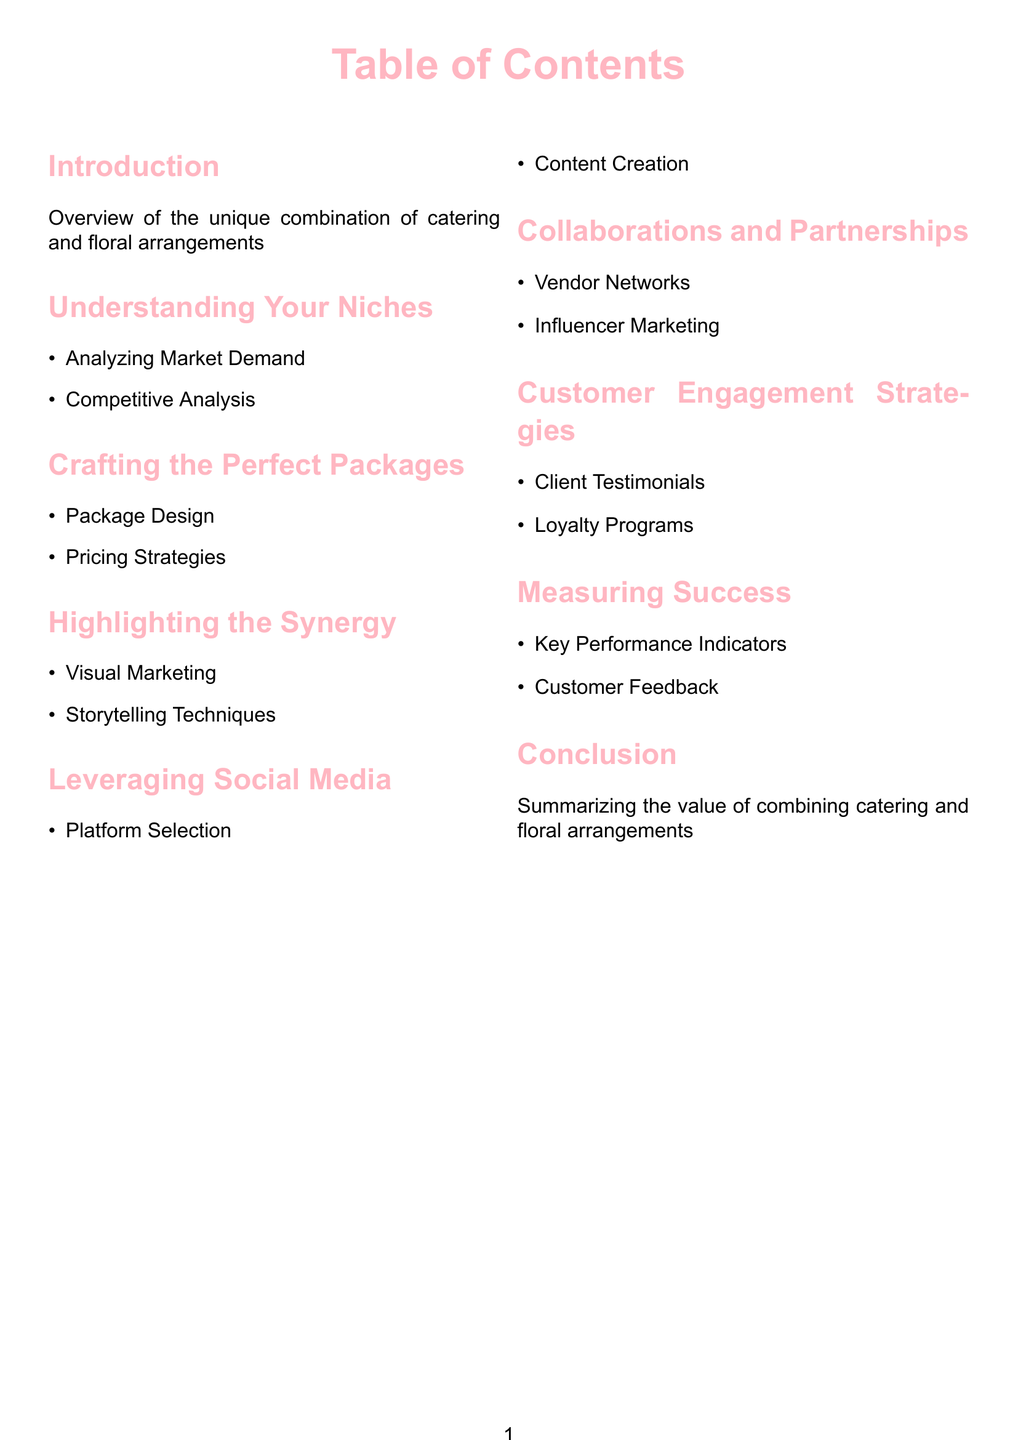What is the first section in the Table of Contents? The first section listed in the Table of Contents is the "Introduction," which provides an overview of the unique combination of catering and floral arrangements.
Answer: Introduction How many main sections are in the document? The document contains a total of eight main sections, as indicated in the Table of Contents.
Answer: Eight What topic is covered under "Understanding Your Niches"? The subtopics under "Understanding Your Niches" include "Analyzing Market Demand" and "Competitive Analysis."
Answer: Analyzing Market Demand, Competitive Analysis Which marketing strategy involves "Client Testimonials"? "Client Testimonials" fall under the section titled "Customer Engagement Strategies," which focuses on engagement with clients.
Answer: Customer Engagement Strategies What is a suggested method for showcasing the synergy between catering and floral arrangements? The section "Highlighting the Synergy" suggests using "Visual Marketing" and "Storytelling Techniques" to showcase the synergy.
Answer: Visual Marketing, Storytelling Techniques What kind of partnership method is mentioned in the document? The document mentions "Vendor Networks" and "Influencer Marketing" as types of collaborations and partnerships.
Answer: Vendor Networks, Influencer Marketing How is the success of marketing strategies measured? The "Measuring Success" section discusses "Key Performance Indicators" and "Customer Feedback" as metrics for evaluating success.
Answer: Key Performance Indicators, Customer Feedback What is the last section of the document? The last section in the Table of Contents is "Conclusion," which summarizes the value of combining catering and floral arrangements.
Answer: Conclusion 